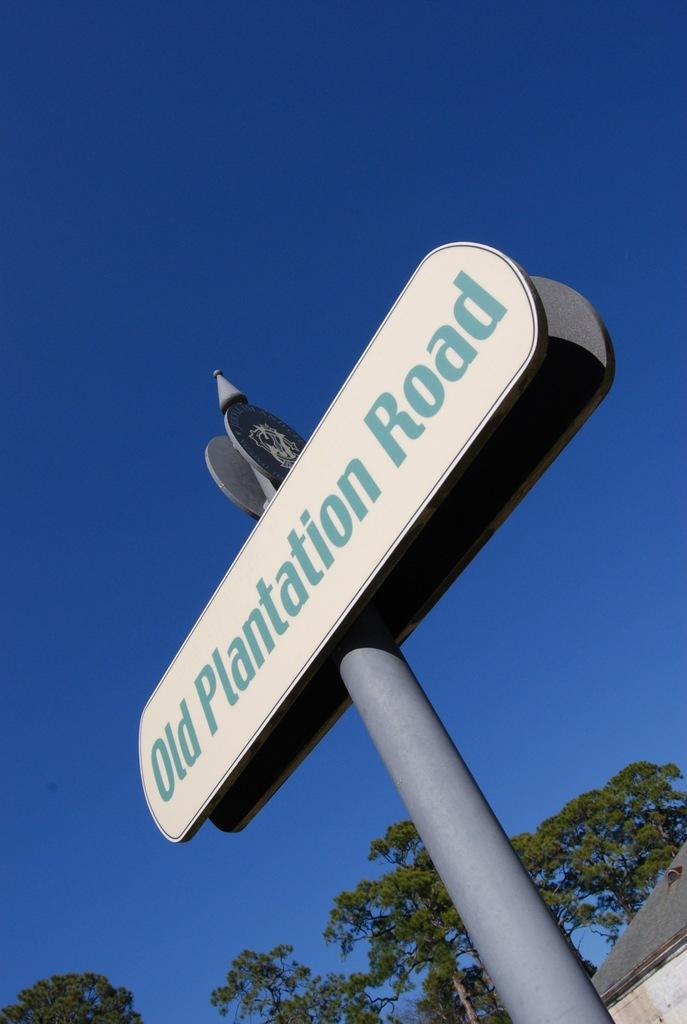What is the main structure in the image? There is a pole in the image with two boards attached to it. What is written on the boards? There is text on the boards. What can be seen at the bottom of the image? There are trees and a house at the bottom of the image. What is visible in the background of the image? The sky is visible in the background of the image. What time of day is it in the image, considering the position of the sun? The image does not show the sun, so it is not possible to determine the time of day based on its position. 